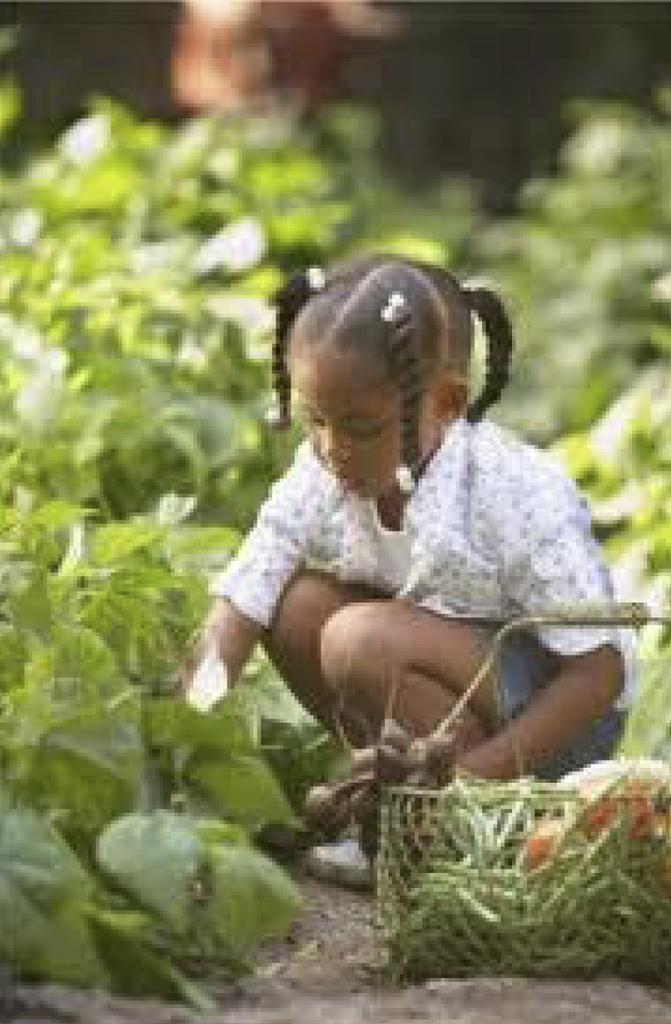Can you describe this image briefly? In the middle of the image a girl is sitting and there is a basket. Behind the girl there are some plants. Background of the image is blur. 